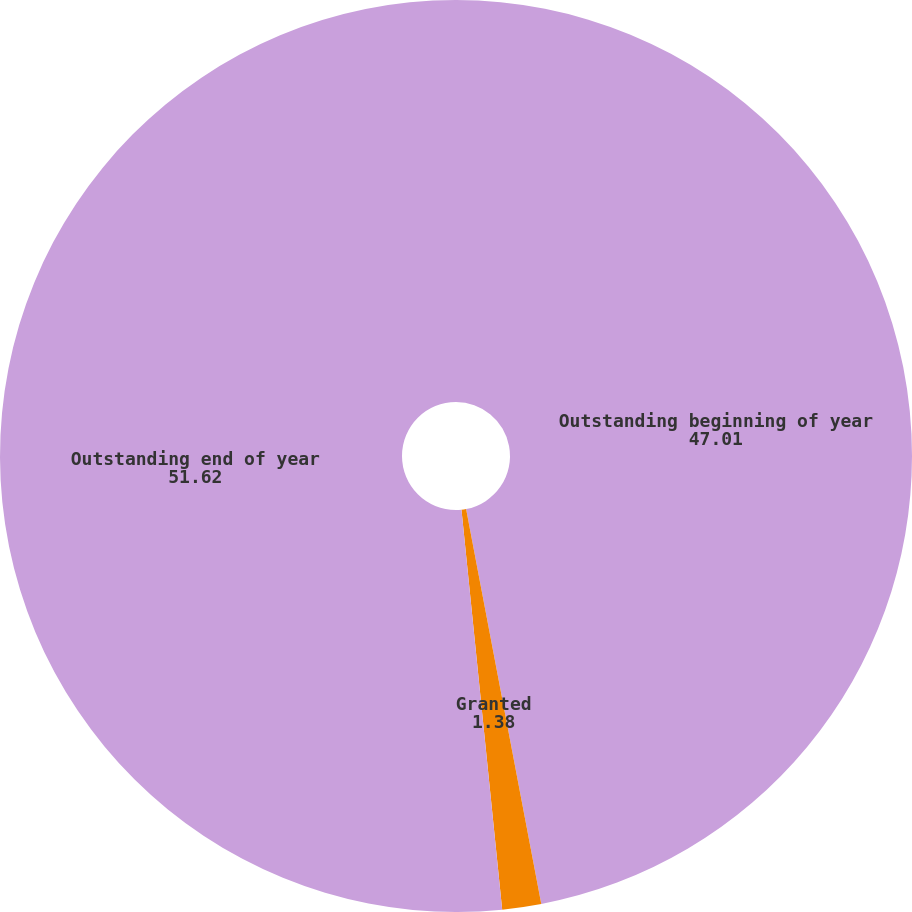Convert chart. <chart><loc_0><loc_0><loc_500><loc_500><pie_chart><fcel>Outstanding beginning of year<fcel>Granted<fcel>Outstanding end of year<nl><fcel>47.01%<fcel>1.38%<fcel>51.62%<nl></chart> 